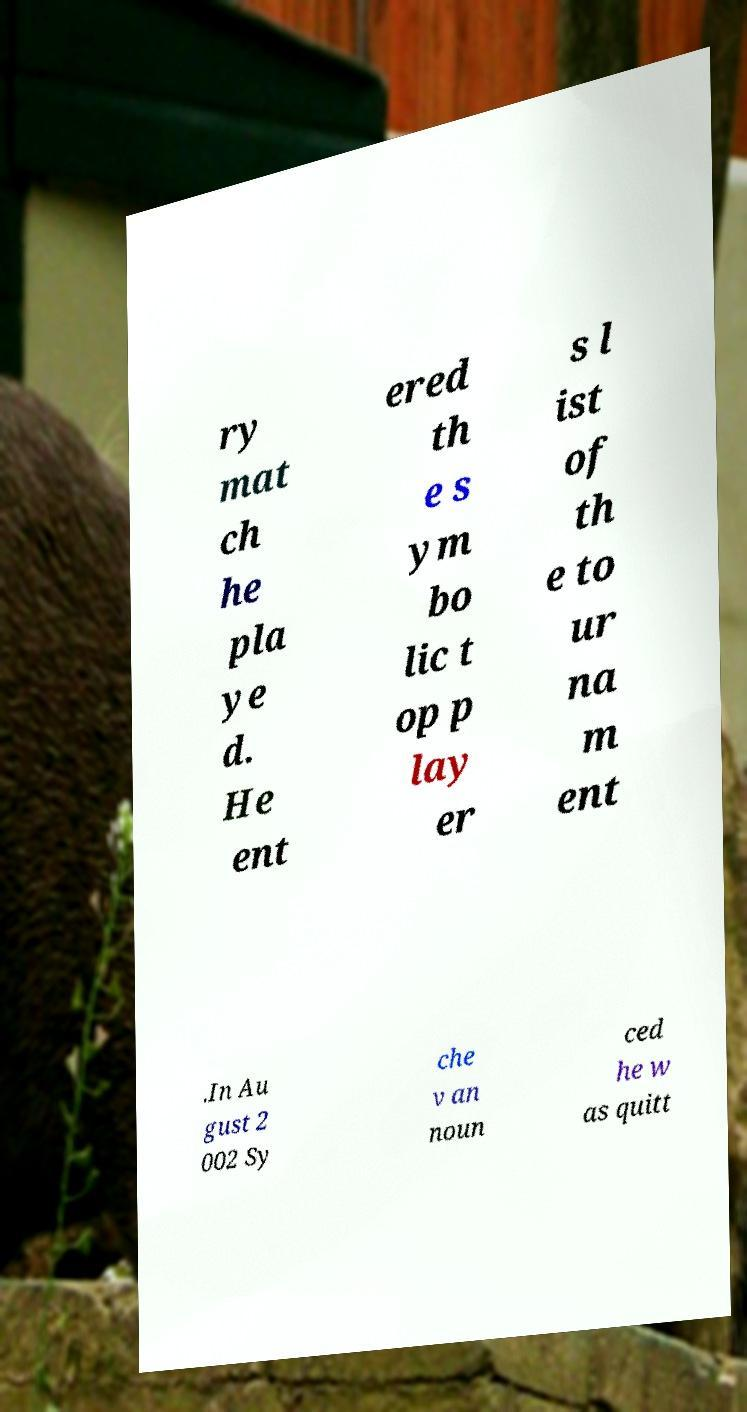What messages or text are displayed in this image? I need them in a readable, typed format. ry mat ch he pla ye d. He ent ered th e s ym bo lic t op p lay er s l ist of th e to ur na m ent .In Au gust 2 002 Sy che v an noun ced he w as quitt 